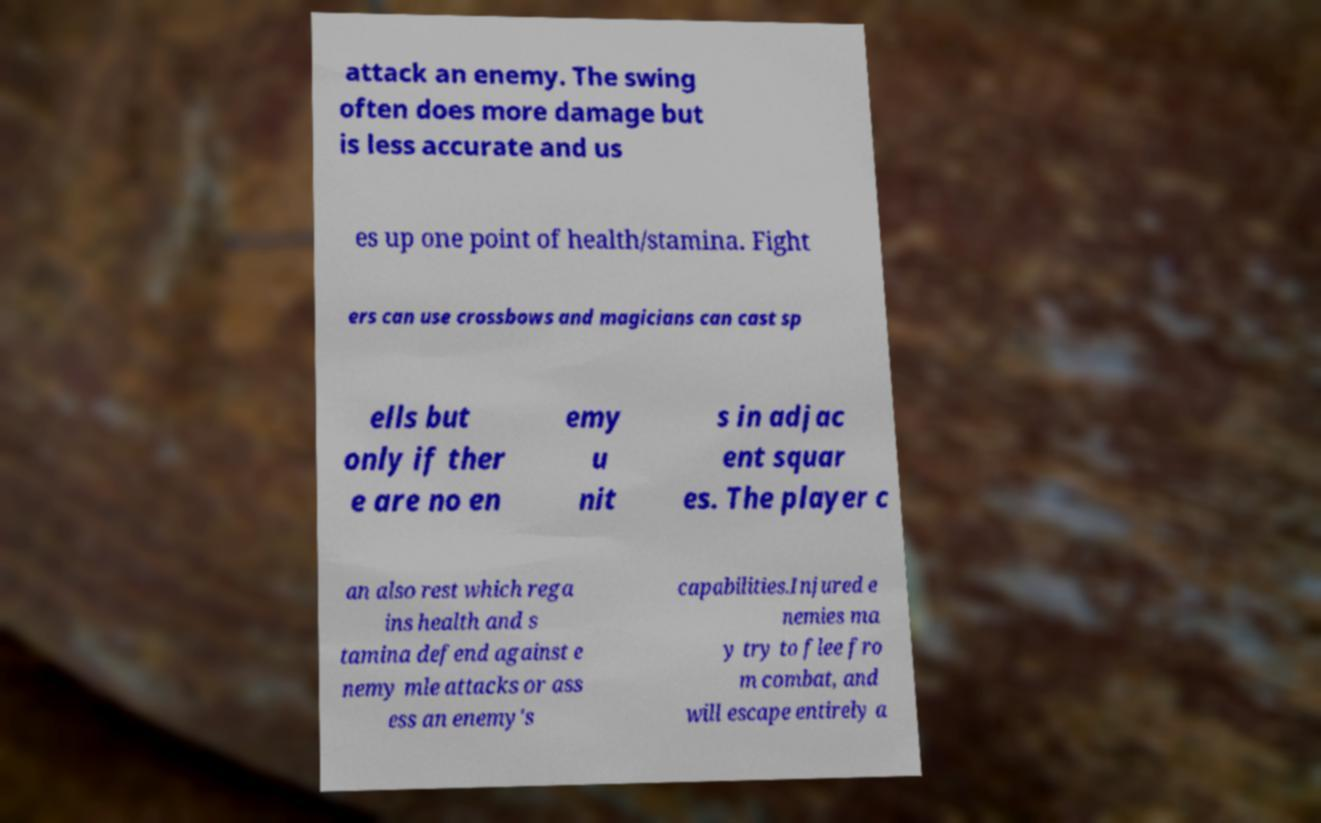Could you extract and type out the text from this image? attack an enemy. The swing often does more damage but is less accurate and us es up one point of health/stamina. Fight ers can use crossbows and magicians can cast sp ells but only if ther e are no en emy u nit s in adjac ent squar es. The player c an also rest which rega ins health and s tamina defend against e nemy mle attacks or ass ess an enemy's capabilities.Injured e nemies ma y try to flee fro m combat, and will escape entirely a 